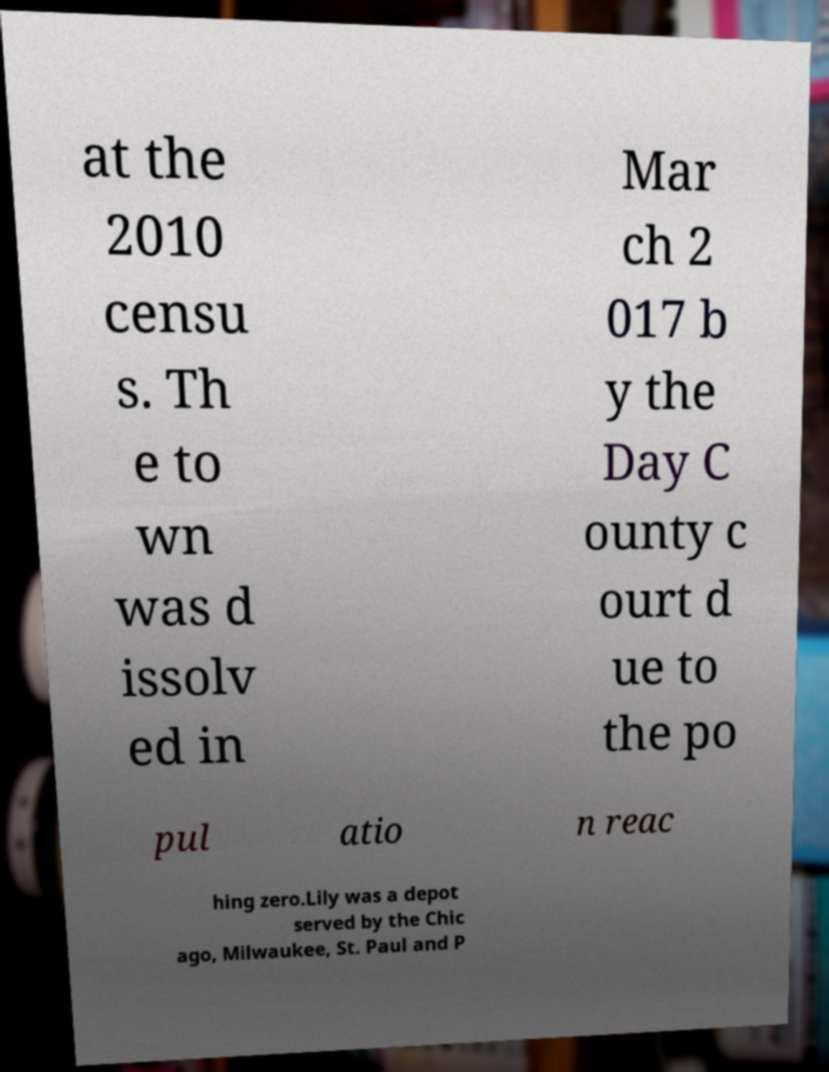Can you read and provide the text displayed in the image?This photo seems to have some interesting text. Can you extract and type it out for me? at the 2010 censu s. Th e to wn was d issolv ed in Mar ch 2 017 b y the Day C ounty c ourt d ue to the po pul atio n reac hing zero.Lily was a depot served by the Chic ago, Milwaukee, St. Paul and P 